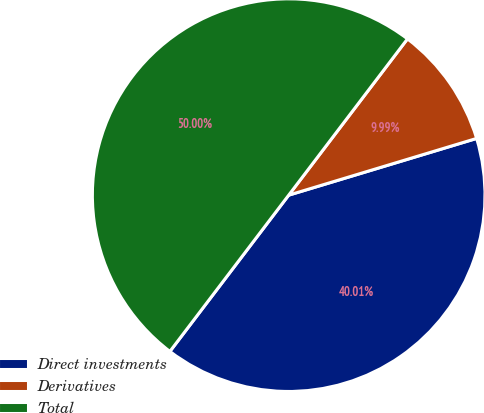<chart> <loc_0><loc_0><loc_500><loc_500><pie_chart><fcel>Direct investments<fcel>Derivatives<fcel>Total<nl><fcel>40.01%<fcel>9.99%<fcel>50.0%<nl></chart> 